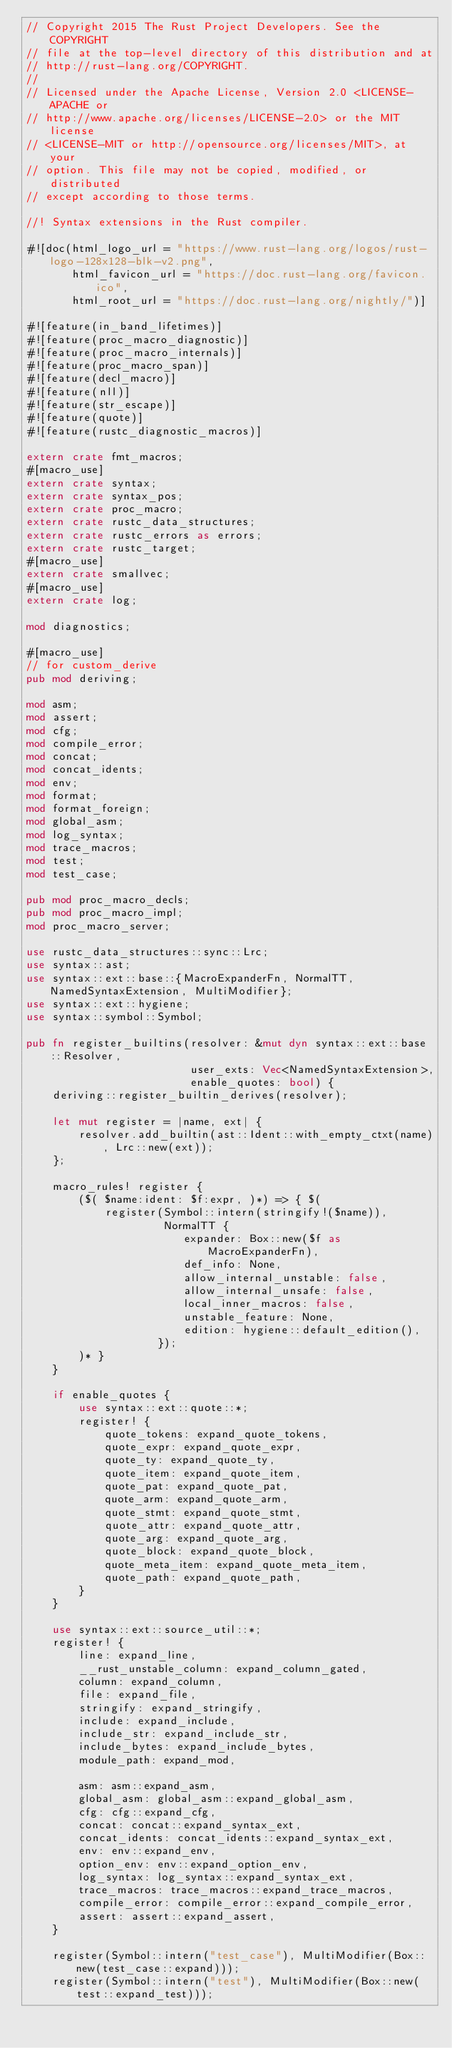<code> <loc_0><loc_0><loc_500><loc_500><_Rust_>// Copyright 2015 The Rust Project Developers. See the COPYRIGHT
// file at the top-level directory of this distribution and at
// http://rust-lang.org/COPYRIGHT.
//
// Licensed under the Apache License, Version 2.0 <LICENSE-APACHE or
// http://www.apache.org/licenses/LICENSE-2.0> or the MIT license
// <LICENSE-MIT or http://opensource.org/licenses/MIT>, at your
// option. This file may not be copied, modified, or distributed
// except according to those terms.

//! Syntax extensions in the Rust compiler.

#![doc(html_logo_url = "https://www.rust-lang.org/logos/rust-logo-128x128-blk-v2.png",
       html_favicon_url = "https://doc.rust-lang.org/favicon.ico",
       html_root_url = "https://doc.rust-lang.org/nightly/")]

#![feature(in_band_lifetimes)]
#![feature(proc_macro_diagnostic)]
#![feature(proc_macro_internals)]
#![feature(proc_macro_span)]
#![feature(decl_macro)]
#![feature(nll)]
#![feature(str_escape)]
#![feature(quote)]
#![feature(rustc_diagnostic_macros)]

extern crate fmt_macros;
#[macro_use]
extern crate syntax;
extern crate syntax_pos;
extern crate proc_macro;
extern crate rustc_data_structures;
extern crate rustc_errors as errors;
extern crate rustc_target;
#[macro_use]
extern crate smallvec;
#[macro_use]
extern crate log;

mod diagnostics;

#[macro_use]
// for custom_derive
pub mod deriving;

mod asm;
mod assert;
mod cfg;
mod compile_error;
mod concat;
mod concat_idents;
mod env;
mod format;
mod format_foreign;
mod global_asm;
mod log_syntax;
mod trace_macros;
mod test;
mod test_case;

pub mod proc_macro_decls;
pub mod proc_macro_impl;
mod proc_macro_server;

use rustc_data_structures::sync::Lrc;
use syntax::ast;
use syntax::ext::base::{MacroExpanderFn, NormalTT, NamedSyntaxExtension, MultiModifier};
use syntax::ext::hygiene;
use syntax::symbol::Symbol;

pub fn register_builtins(resolver: &mut dyn syntax::ext::base::Resolver,
                         user_exts: Vec<NamedSyntaxExtension>,
                         enable_quotes: bool) {
    deriving::register_builtin_derives(resolver);

    let mut register = |name, ext| {
        resolver.add_builtin(ast::Ident::with_empty_ctxt(name), Lrc::new(ext));
    };

    macro_rules! register {
        ($( $name:ident: $f:expr, )*) => { $(
            register(Symbol::intern(stringify!($name)),
                     NormalTT {
                        expander: Box::new($f as MacroExpanderFn),
                        def_info: None,
                        allow_internal_unstable: false,
                        allow_internal_unsafe: false,
                        local_inner_macros: false,
                        unstable_feature: None,
                        edition: hygiene::default_edition(),
                    });
        )* }
    }

    if enable_quotes {
        use syntax::ext::quote::*;
        register! {
            quote_tokens: expand_quote_tokens,
            quote_expr: expand_quote_expr,
            quote_ty: expand_quote_ty,
            quote_item: expand_quote_item,
            quote_pat: expand_quote_pat,
            quote_arm: expand_quote_arm,
            quote_stmt: expand_quote_stmt,
            quote_attr: expand_quote_attr,
            quote_arg: expand_quote_arg,
            quote_block: expand_quote_block,
            quote_meta_item: expand_quote_meta_item,
            quote_path: expand_quote_path,
        }
    }

    use syntax::ext::source_util::*;
    register! {
        line: expand_line,
        __rust_unstable_column: expand_column_gated,
        column: expand_column,
        file: expand_file,
        stringify: expand_stringify,
        include: expand_include,
        include_str: expand_include_str,
        include_bytes: expand_include_bytes,
        module_path: expand_mod,

        asm: asm::expand_asm,
        global_asm: global_asm::expand_global_asm,
        cfg: cfg::expand_cfg,
        concat: concat::expand_syntax_ext,
        concat_idents: concat_idents::expand_syntax_ext,
        env: env::expand_env,
        option_env: env::expand_option_env,
        log_syntax: log_syntax::expand_syntax_ext,
        trace_macros: trace_macros::expand_trace_macros,
        compile_error: compile_error::expand_compile_error,
        assert: assert::expand_assert,
    }

    register(Symbol::intern("test_case"), MultiModifier(Box::new(test_case::expand)));
    register(Symbol::intern("test"), MultiModifier(Box::new(test::expand_test)));</code> 